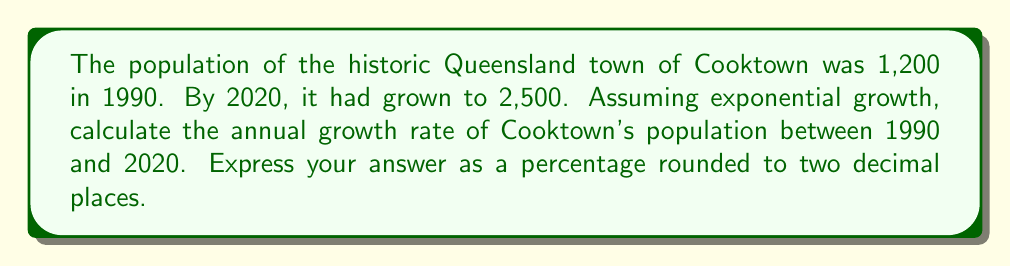Solve this math problem. Let's approach this step-by-step using the exponential growth formula:

1) The exponential growth formula is:
   $$A = P(1 + r)^t$$
   Where:
   $A$ = Final amount
   $P$ = Initial amount
   $r$ = Annual growth rate (in decimal form)
   $t$ = Time in years

2) We know:
   $P = 1,200$ (population in 1990)
   $A = 2,500$ (population in 2020)
   $t = 30$ years (from 1990 to 2020)

3) Let's plug these into our formula:
   $$2,500 = 1,200(1 + r)^{30}$$

4) Divide both sides by 1,200:
   $$\frac{2,500}{1,200} = (1 + r)^{30}$$

5) Take the 30th root of both sides:
   $$\sqrt[30]{\frac{2,500}{1,200}} = 1 + r$$

6) Subtract 1 from both sides:
   $$\sqrt[30]{\frac{2,500}{1,200}} - 1 = r$$

7) Calculate:
   $$r \approx 0.0249$$

8) Convert to a percentage:
   $$0.0249 \times 100 = 2.49\%$$

9) Round to two decimal places: 2.49%
Answer: 2.49% 